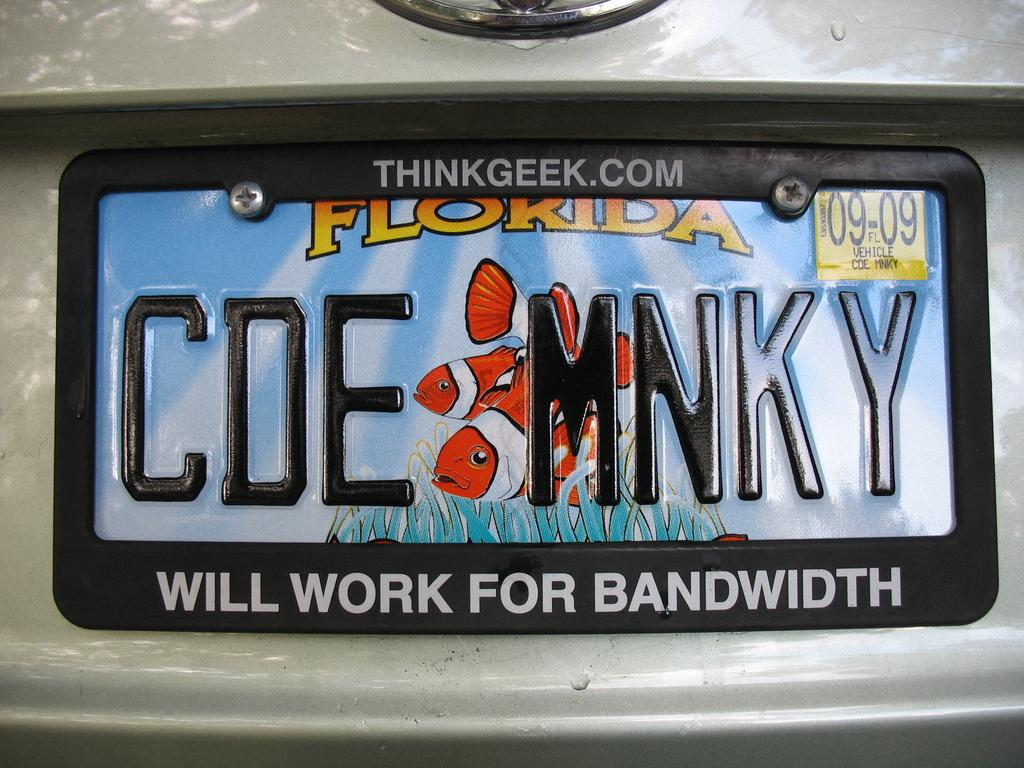Provide a one-sentence caption for the provided image. A Florida license plate is attached to the back of a car. 